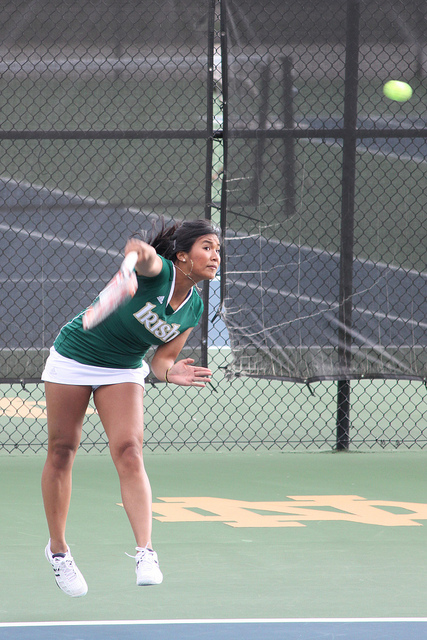Identify the text displayed in this image. IRish 